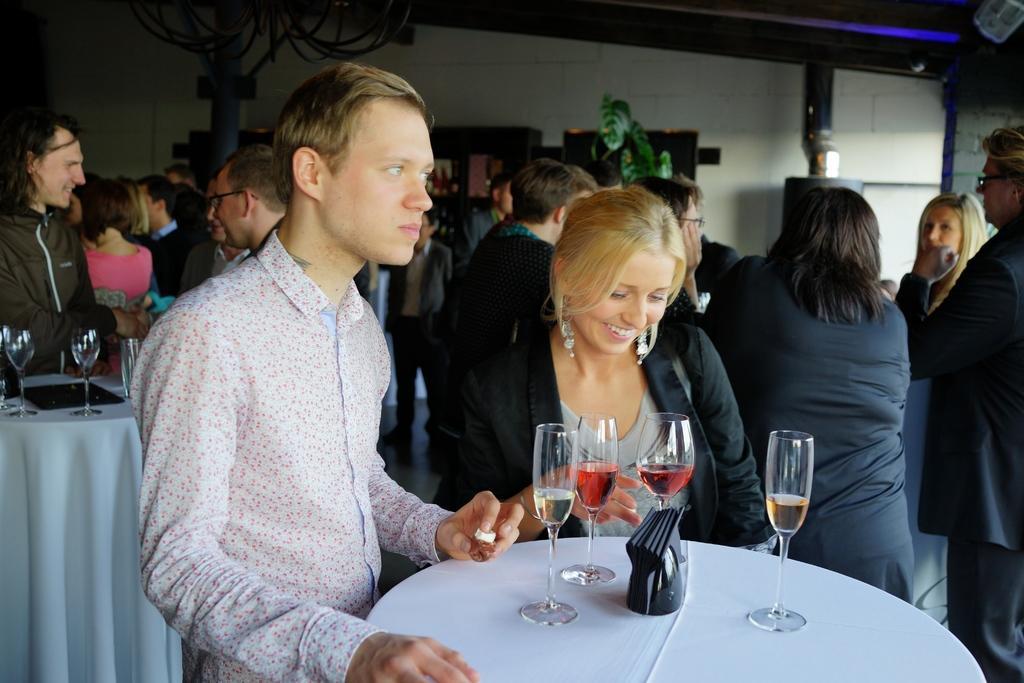Could you give a brief overview of what you see in this image? In this picture there are group of people who are standing. There are few glasses on the table. There is a plant and light. 